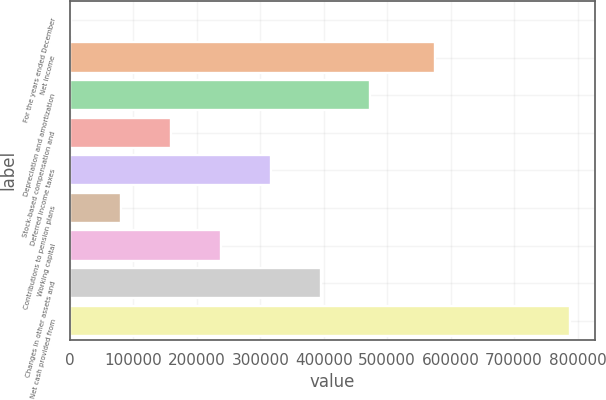Convert chart to OTSL. <chart><loc_0><loc_0><loc_500><loc_500><bar_chart><fcel>For the years ended December<fcel>Net income<fcel>Depreciation and amortization<fcel>Stock-based compensation and<fcel>Deferred income taxes<fcel>Contributions to pension plans<fcel>Working capital<fcel>Changes in other assets and<fcel>Net cash provided from<nl><fcel>2004<fcel>574637<fcel>473454<fcel>159154<fcel>316304<fcel>80579<fcel>237729<fcel>394879<fcel>787754<nl></chart> 